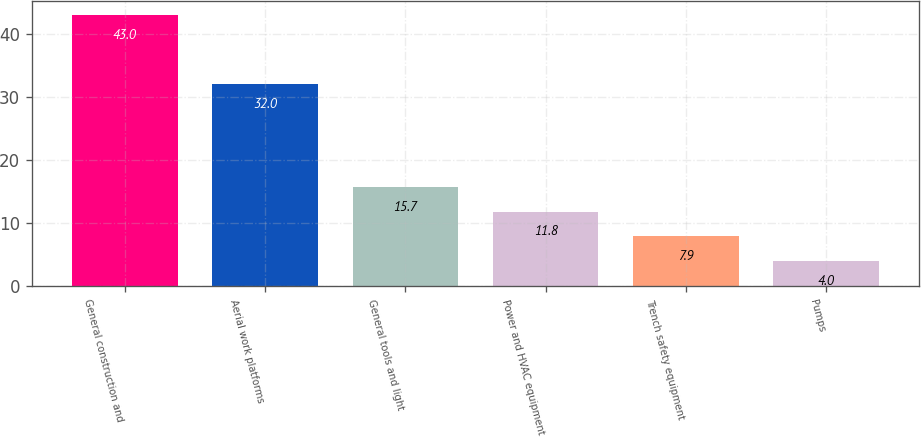Convert chart. <chart><loc_0><loc_0><loc_500><loc_500><bar_chart><fcel>General construction and<fcel>Aerial work platforms<fcel>General tools and light<fcel>Power and HVAC equipment<fcel>Trench safety equipment<fcel>Pumps<nl><fcel>43<fcel>32<fcel>15.7<fcel>11.8<fcel>7.9<fcel>4<nl></chart> 